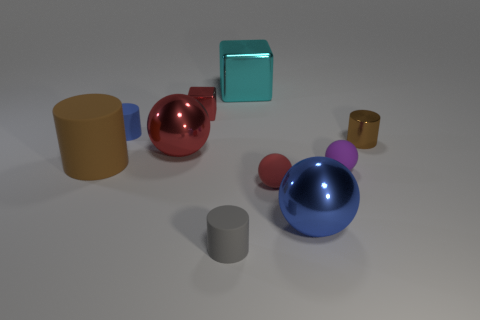Does the brown rubber thing have the same shape as the big blue metallic object?
Provide a succinct answer. No. What is the material of the brown cylinder in front of the big metallic sphere to the left of the small gray thing?
Your answer should be compact. Rubber. There is a rubber thing in front of the blue object in front of the red object that is in front of the large brown cylinder; what size is it?
Make the answer very short. Small. Does the tiny red rubber object have the same shape as the blue object behind the tiny brown shiny cylinder?
Ensure brevity in your answer.  No. What is the material of the cyan object?
Keep it short and to the point. Metal. What number of metallic things are purple balls or large blue things?
Provide a succinct answer. 1. Are there fewer gray things that are on the left side of the red block than big metallic cubes that are in front of the big rubber cylinder?
Ensure brevity in your answer.  No. Is there a large red ball that is on the right side of the brown thing right of the tiny rubber sphere that is on the left side of the small purple object?
Ensure brevity in your answer.  No. There is a tiny object that is the same color as the small metal cube; what is its material?
Offer a very short reply. Rubber. Do the small red thing behind the small blue rubber thing and the metallic thing on the left side of the small red cube have the same shape?
Your answer should be very brief. No. 